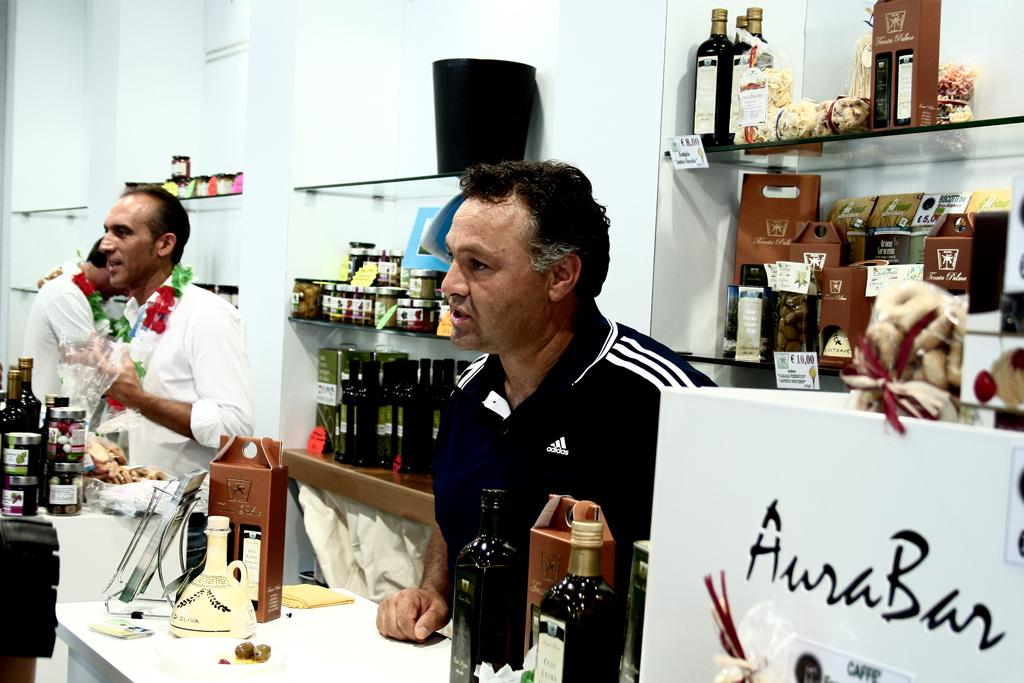<image>
Provide a brief description of the given image. Men stand behind the counter at Aura Bar. 